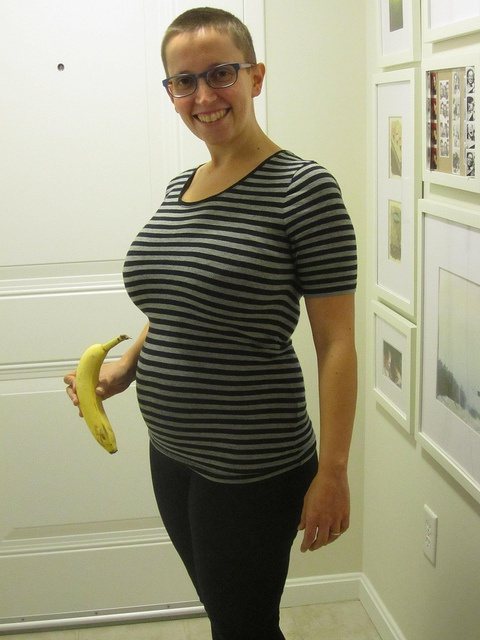Describe the objects in this image and their specific colors. I can see people in white, black, gray, and olive tones and banana in white, olive, and khaki tones in this image. 